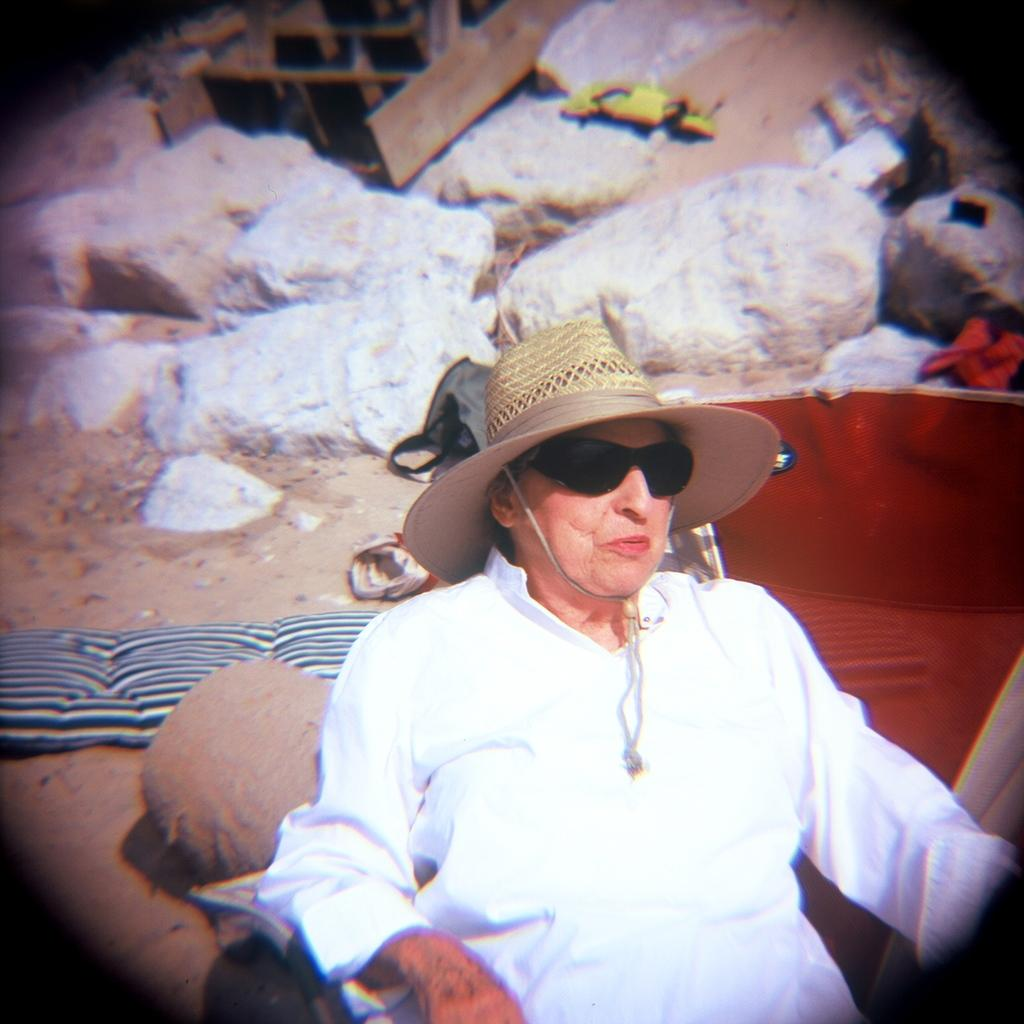What is the person on the right side of the image wearing? The person is wearing a white dress, sunglasses, and a cap. What is the person on the right side of the image doing? The person is sitting. What can be seen in the background of the image? There are rocks and a wooden item on the sand surface in the background. What type of quill is the person holding in the image? There is no quill present in the image. Can you tell me how the engine is functioning in the image? There is no engine present in the image. 